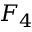Convert formula to latex. <formula><loc_0><loc_0><loc_500><loc_500>F _ { 4 }</formula> 